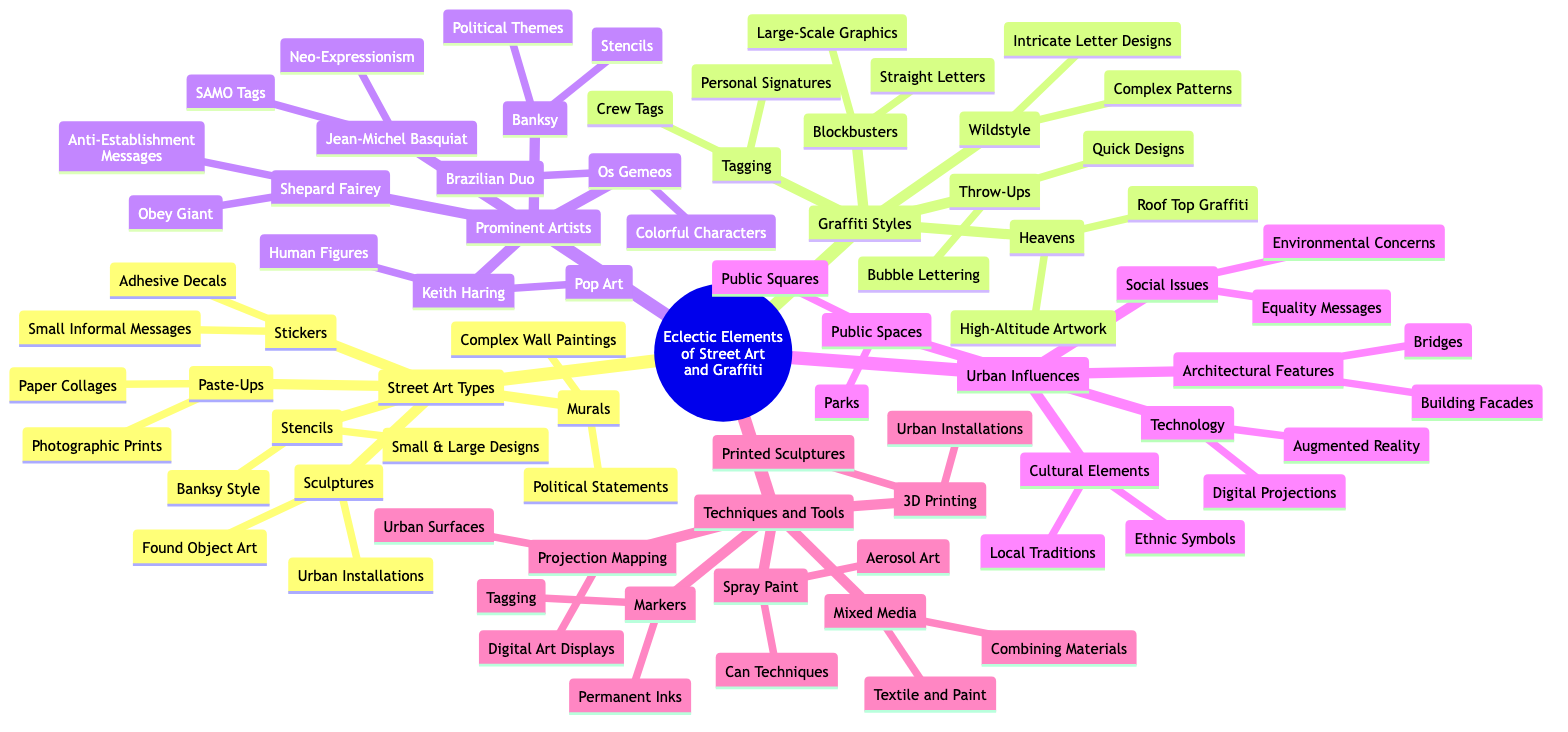What are the two categories of elements in this mind map? The mind map categorizes the elements into "Street Art Types" and "Graffiti Styles", among others, each as a major branch of the main topic.
Answer: Street Art Types, Graffiti Styles How many types of Street Art are listed? The diagram contains five distinct types of Street Art: Murals, Stencils, Paste-Ups, Stickers, and Sculptures.
Answer: 5 Which artist is associated with political themes and stencils? By analyzing the "Prominent Artists" section, Banksy is explicitly mentioned as the artist linked with political themes and uses stencils in his work.
Answer: Banksy What is a common technique used for aerosol art? Within the "Techniques and Tools" section under "Spray Paint", the method known as aerosol art is clearly classified.
Answer: Aerosol Art Which urban influence category includes digital projections? Evaluating the "Urban Influences" section, "Technology" is the category that mentions digital projections as a notable concept.
Answer: Technology What type of graffiti style uses intricate letter designs? Looking at the "Graffiti Styles" branch, the "Wildstyle" subcategory clearly points to intricate letter designs as a defining feature.
Answer: Wildstyle Name a technique that combines different materials. In the "Techniques and Tools" section, "Mixed Media" is cited as the technique that involves combining various materials.
Answer: Mixed Media How many styles of graffiti are listed in the diagram? The "Graffiti Styles" section outlines five different styles: Tagging, Throw-Ups, Wildstyle, Blockbusters, and Heavens.
Answer: 5 What is the unique quality of "Heavens" style in graffiti? The "Heavens" style is defined by its unique quality of being high-altitude artwork, as noted in its description under the "Graffiti Styles" branch.
Answer: High-Altitude Artwork 